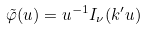Convert formula to latex. <formula><loc_0><loc_0><loc_500><loc_500>\tilde { \varphi } ( u ) = u ^ { - 1 } I _ { \nu } ( k ^ { \prime } u )</formula> 